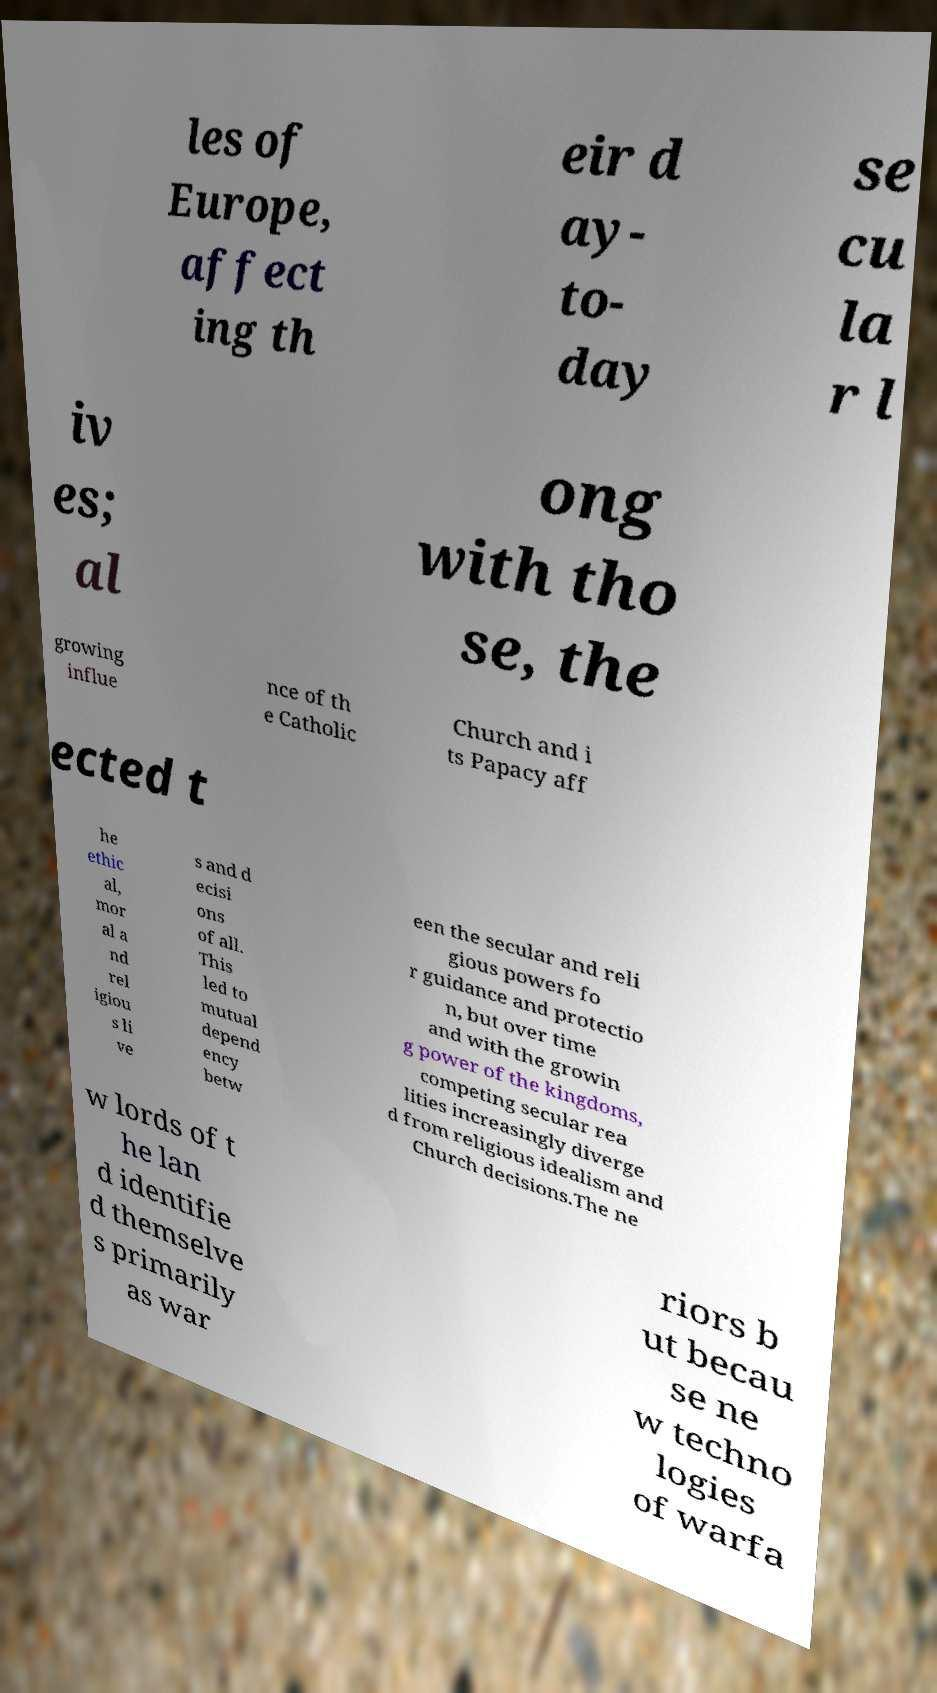Could you extract and type out the text from this image? les of Europe, affect ing th eir d ay- to- day se cu la r l iv es; al ong with tho se, the growing influe nce of th e Catholic Church and i ts Papacy aff ected t he ethic al, mor al a nd rel igiou s li ve s and d ecisi ons of all. This led to mutual depend ency betw een the secular and reli gious powers fo r guidance and protectio n, but over time and with the growin g power of the kingdoms, competing secular rea lities increasingly diverge d from religious idealism and Church decisions.The ne w lords of t he lan d identifie d themselve s primarily as war riors b ut becau se ne w techno logies of warfa 